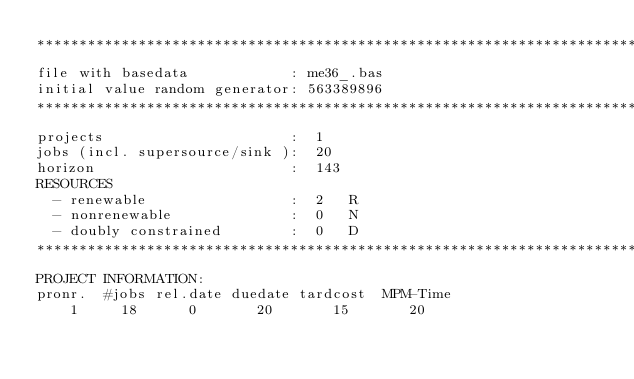Convert code to text. <code><loc_0><loc_0><loc_500><loc_500><_ObjectiveC_>************************************************************************
file with basedata            : me36_.bas
initial value random generator: 563389896
************************************************************************
projects                      :  1
jobs (incl. supersource/sink ):  20
horizon                       :  143
RESOURCES
  - renewable                 :  2   R
  - nonrenewable              :  0   N
  - doubly constrained        :  0   D
************************************************************************
PROJECT INFORMATION:
pronr.  #jobs rel.date duedate tardcost  MPM-Time
    1     18      0       20       15       20</code> 